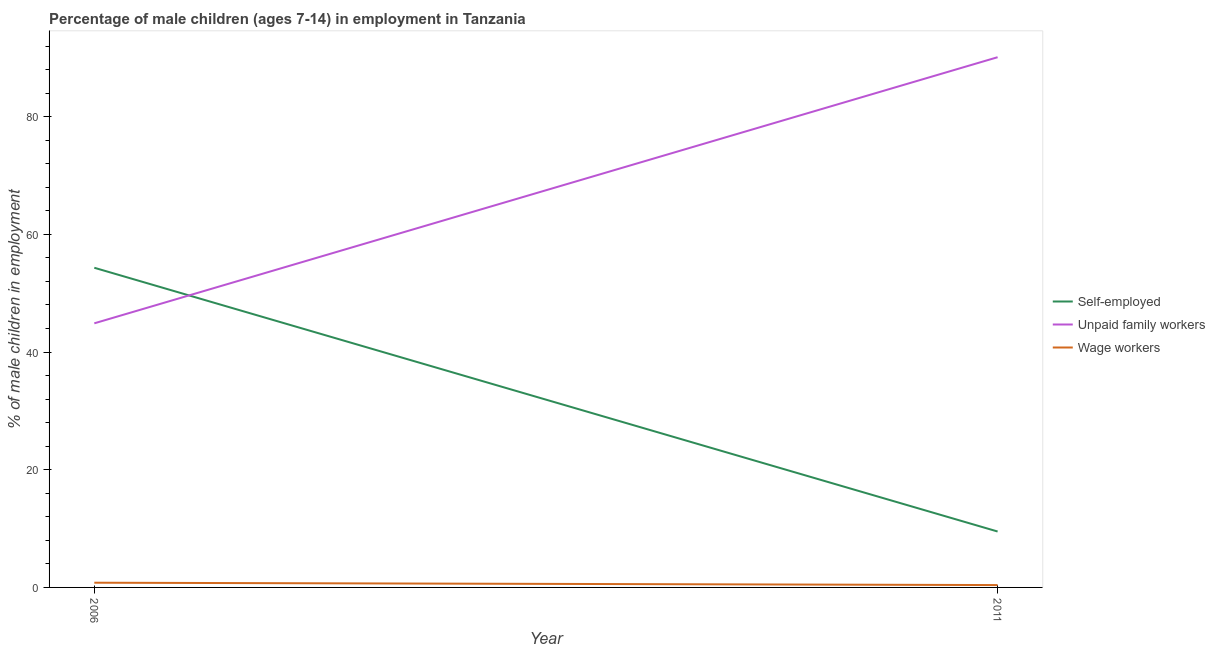How many different coloured lines are there?
Your response must be concise. 3. What is the percentage of self employed children in 2006?
Your answer should be compact. 54.32. Across all years, what is the maximum percentage of self employed children?
Provide a succinct answer. 54.32. Across all years, what is the minimum percentage of children employed as unpaid family workers?
Your answer should be very brief. 44.88. In which year was the percentage of self employed children maximum?
Provide a succinct answer. 2006. What is the total percentage of children employed as wage workers in the graph?
Offer a very short reply. 1.2. What is the difference between the percentage of self employed children in 2006 and that in 2011?
Keep it short and to the point. 44.82. What is the difference between the percentage of self employed children in 2006 and the percentage of children employed as wage workers in 2011?
Give a very brief answer. 53.92. What is the average percentage of children employed as unpaid family workers per year?
Make the answer very short. 67.49. In the year 2006, what is the difference between the percentage of children employed as unpaid family workers and percentage of children employed as wage workers?
Offer a very short reply. 44.08. In how many years, is the percentage of self employed children greater than 12 %?
Your answer should be very brief. 1. What is the ratio of the percentage of self employed children in 2006 to that in 2011?
Provide a succinct answer. 5.72. Is the percentage of children employed as unpaid family workers in 2006 less than that in 2011?
Your answer should be compact. Yes. Is the percentage of children employed as wage workers strictly less than the percentage of self employed children over the years?
Your response must be concise. Yes. How many lines are there?
Give a very brief answer. 3. How many years are there in the graph?
Offer a terse response. 2. Where does the legend appear in the graph?
Offer a terse response. Center right. What is the title of the graph?
Keep it short and to the point. Percentage of male children (ages 7-14) in employment in Tanzania. What is the label or title of the Y-axis?
Ensure brevity in your answer.  % of male children in employment. What is the % of male children in employment in Self-employed in 2006?
Your answer should be very brief. 54.32. What is the % of male children in employment in Unpaid family workers in 2006?
Give a very brief answer. 44.88. What is the % of male children in employment of Self-employed in 2011?
Your answer should be compact. 9.5. What is the % of male children in employment of Unpaid family workers in 2011?
Offer a terse response. 90.1. Across all years, what is the maximum % of male children in employment in Self-employed?
Offer a terse response. 54.32. Across all years, what is the maximum % of male children in employment of Unpaid family workers?
Provide a succinct answer. 90.1. Across all years, what is the maximum % of male children in employment in Wage workers?
Your answer should be very brief. 0.8. Across all years, what is the minimum % of male children in employment of Unpaid family workers?
Make the answer very short. 44.88. What is the total % of male children in employment of Self-employed in the graph?
Offer a terse response. 63.82. What is the total % of male children in employment in Unpaid family workers in the graph?
Your answer should be compact. 134.98. What is the total % of male children in employment in Wage workers in the graph?
Offer a terse response. 1.2. What is the difference between the % of male children in employment of Self-employed in 2006 and that in 2011?
Give a very brief answer. 44.82. What is the difference between the % of male children in employment in Unpaid family workers in 2006 and that in 2011?
Keep it short and to the point. -45.22. What is the difference between the % of male children in employment of Self-employed in 2006 and the % of male children in employment of Unpaid family workers in 2011?
Your answer should be compact. -35.78. What is the difference between the % of male children in employment of Self-employed in 2006 and the % of male children in employment of Wage workers in 2011?
Ensure brevity in your answer.  53.92. What is the difference between the % of male children in employment of Unpaid family workers in 2006 and the % of male children in employment of Wage workers in 2011?
Provide a succinct answer. 44.48. What is the average % of male children in employment of Self-employed per year?
Your response must be concise. 31.91. What is the average % of male children in employment in Unpaid family workers per year?
Your answer should be compact. 67.49. What is the average % of male children in employment of Wage workers per year?
Offer a very short reply. 0.6. In the year 2006, what is the difference between the % of male children in employment in Self-employed and % of male children in employment in Unpaid family workers?
Provide a short and direct response. 9.44. In the year 2006, what is the difference between the % of male children in employment in Self-employed and % of male children in employment in Wage workers?
Your answer should be compact. 53.52. In the year 2006, what is the difference between the % of male children in employment in Unpaid family workers and % of male children in employment in Wage workers?
Your answer should be very brief. 44.08. In the year 2011, what is the difference between the % of male children in employment in Self-employed and % of male children in employment in Unpaid family workers?
Offer a terse response. -80.6. In the year 2011, what is the difference between the % of male children in employment in Unpaid family workers and % of male children in employment in Wage workers?
Provide a succinct answer. 89.7. What is the ratio of the % of male children in employment of Self-employed in 2006 to that in 2011?
Offer a terse response. 5.72. What is the ratio of the % of male children in employment of Unpaid family workers in 2006 to that in 2011?
Your answer should be compact. 0.5. What is the difference between the highest and the second highest % of male children in employment of Self-employed?
Provide a short and direct response. 44.82. What is the difference between the highest and the second highest % of male children in employment in Unpaid family workers?
Make the answer very short. 45.22. What is the difference between the highest and the second highest % of male children in employment in Wage workers?
Your answer should be compact. 0.4. What is the difference between the highest and the lowest % of male children in employment of Self-employed?
Your answer should be very brief. 44.82. What is the difference between the highest and the lowest % of male children in employment in Unpaid family workers?
Keep it short and to the point. 45.22. What is the difference between the highest and the lowest % of male children in employment of Wage workers?
Offer a terse response. 0.4. 